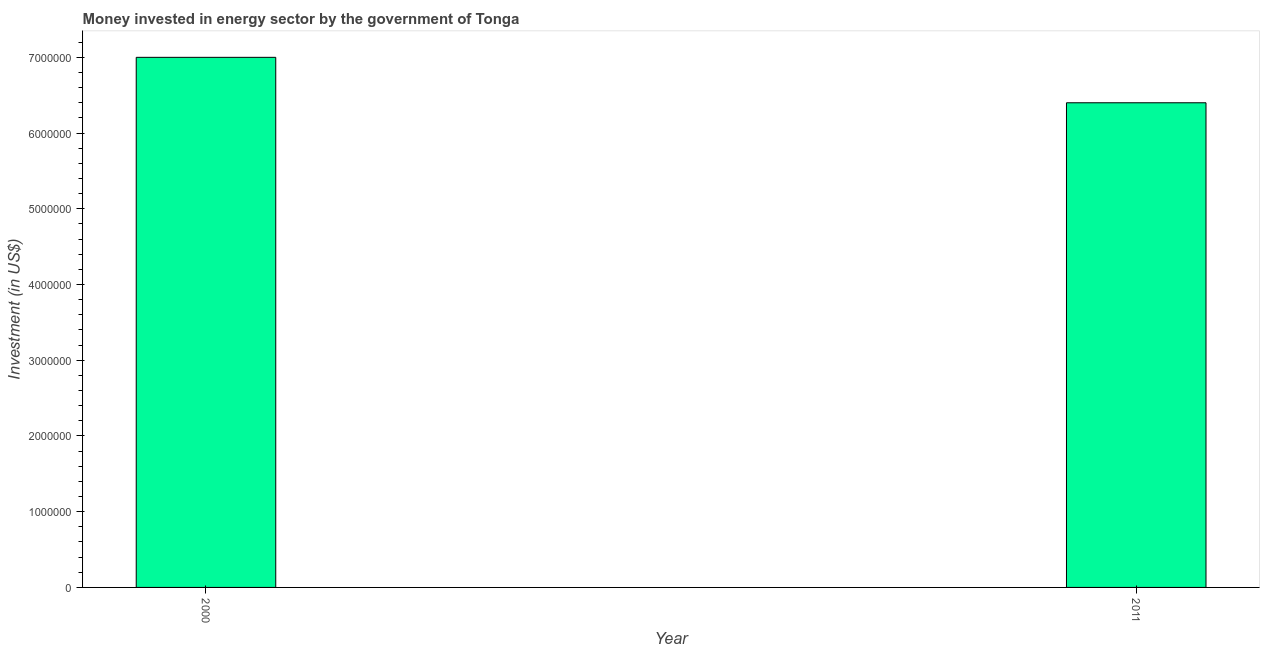Does the graph contain any zero values?
Provide a short and direct response. No. Does the graph contain grids?
Ensure brevity in your answer.  No. What is the title of the graph?
Your answer should be very brief. Money invested in energy sector by the government of Tonga. What is the label or title of the X-axis?
Your response must be concise. Year. What is the label or title of the Y-axis?
Offer a very short reply. Investment (in US$). What is the investment in energy in 2000?
Your answer should be compact. 7.00e+06. Across all years, what is the minimum investment in energy?
Your answer should be compact. 6.40e+06. What is the sum of the investment in energy?
Keep it short and to the point. 1.34e+07. What is the difference between the investment in energy in 2000 and 2011?
Ensure brevity in your answer.  6.00e+05. What is the average investment in energy per year?
Offer a terse response. 6.70e+06. What is the median investment in energy?
Your response must be concise. 6.70e+06. In how many years, is the investment in energy greater than 4400000 US$?
Make the answer very short. 2. What is the ratio of the investment in energy in 2000 to that in 2011?
Your answer should be compact. 1.09. In how many years, is the investment in energy greater than the average investment in energy taken over all years?
Provide a succinct answer. 1. How many bars are there?
Your answer should be very brief. 2. Are all the bars in the graph horizontal?
Your answer should be very brief. No. Are the values on the major ticks of Y-axis written in scientific E-notation?
Make the answer very short. No. What is the Investment (in US$) of 2000?
Your answer should be compact. 7.00e+06. What is the Investment (in US$) of 2011?
Your answer should be very brief. 6.40e+06. What is the ratio of the Investment (in US$) in 2000 to that in 2011?
Make the answer very short. 1.09. 